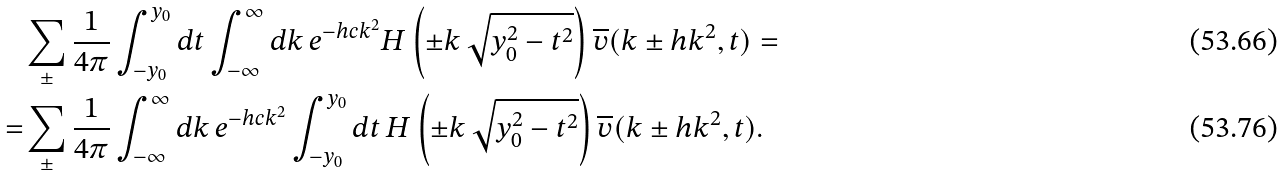<formula> <loc_0><loc_0><loc_500><loc_500>& \sum _ { \pm } \frac { 1 } { 4 \pi } \int _ { - y _ { 0 } } ^ { y _ { 0 } } d t \int _ { - \infty } ^ { \infty } d k \, e ^ { - h c k ^ { 2 } } H \left ( \pm k \, \sqrt { y _ { 0 } ^ { 2 } - t ^ { 2 } } \right ) \overline { v } ( k \pm h k ^ { 2 } , t ) = \\ = & \sum _ { \pm } \frac { 1 } { 4 \pi } \int _ { - \infty } ^ { \infty } d k \, e ^ { - h c k ^ { 2 } } \int _ { - y _ { 0 } } ^ { y _ { 0 } } d t \, H \left ( \pm k \, \sqrt { y _ { 0 } ^ { 2 } - t ^ { 2 } } \right ) \overline { v } ( k \pm h k ^ { 2 } , t ) .</formula> 